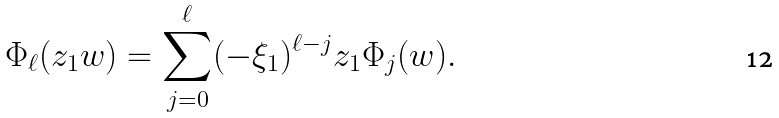Convert formula to latex. <formula><loc_0><loc_0><loc_500><loc_500>\Phi _ { \ell } ( z _ { 1 } w ) = \sum _ { j = 0 } ^ { \ell } ( - \xi _ { 1 } ) ^ { \ell - j } z _ { 1 } \Phi _ { j } ( w ) .</formula> 